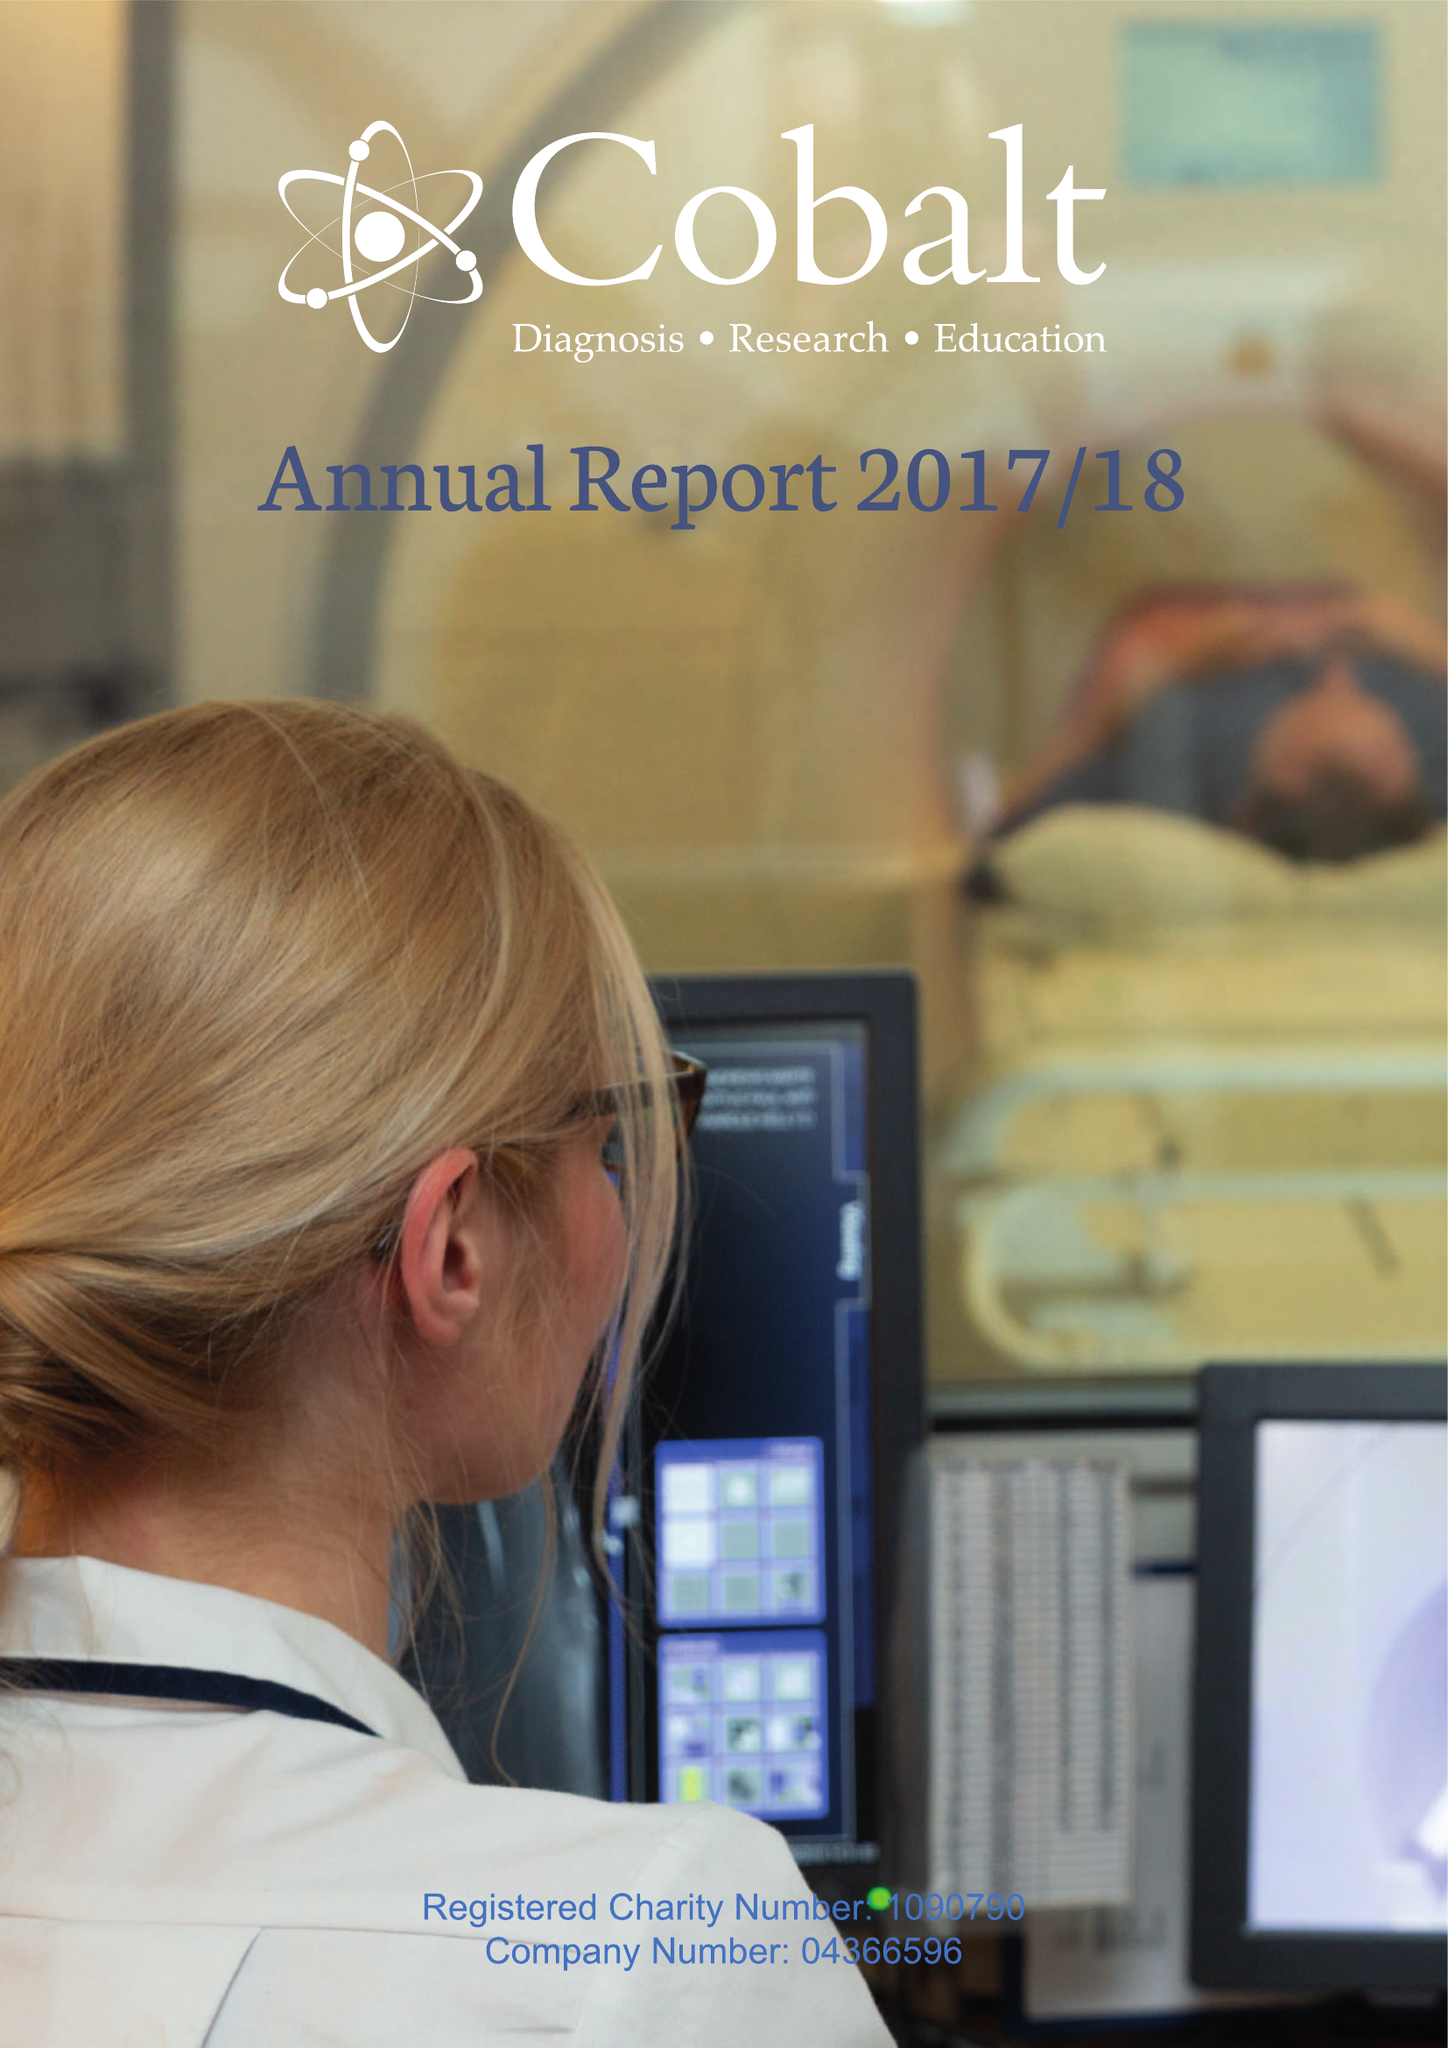What is the value for the report_date?
Answer the question using a single word or phrase. 2018-03-31 